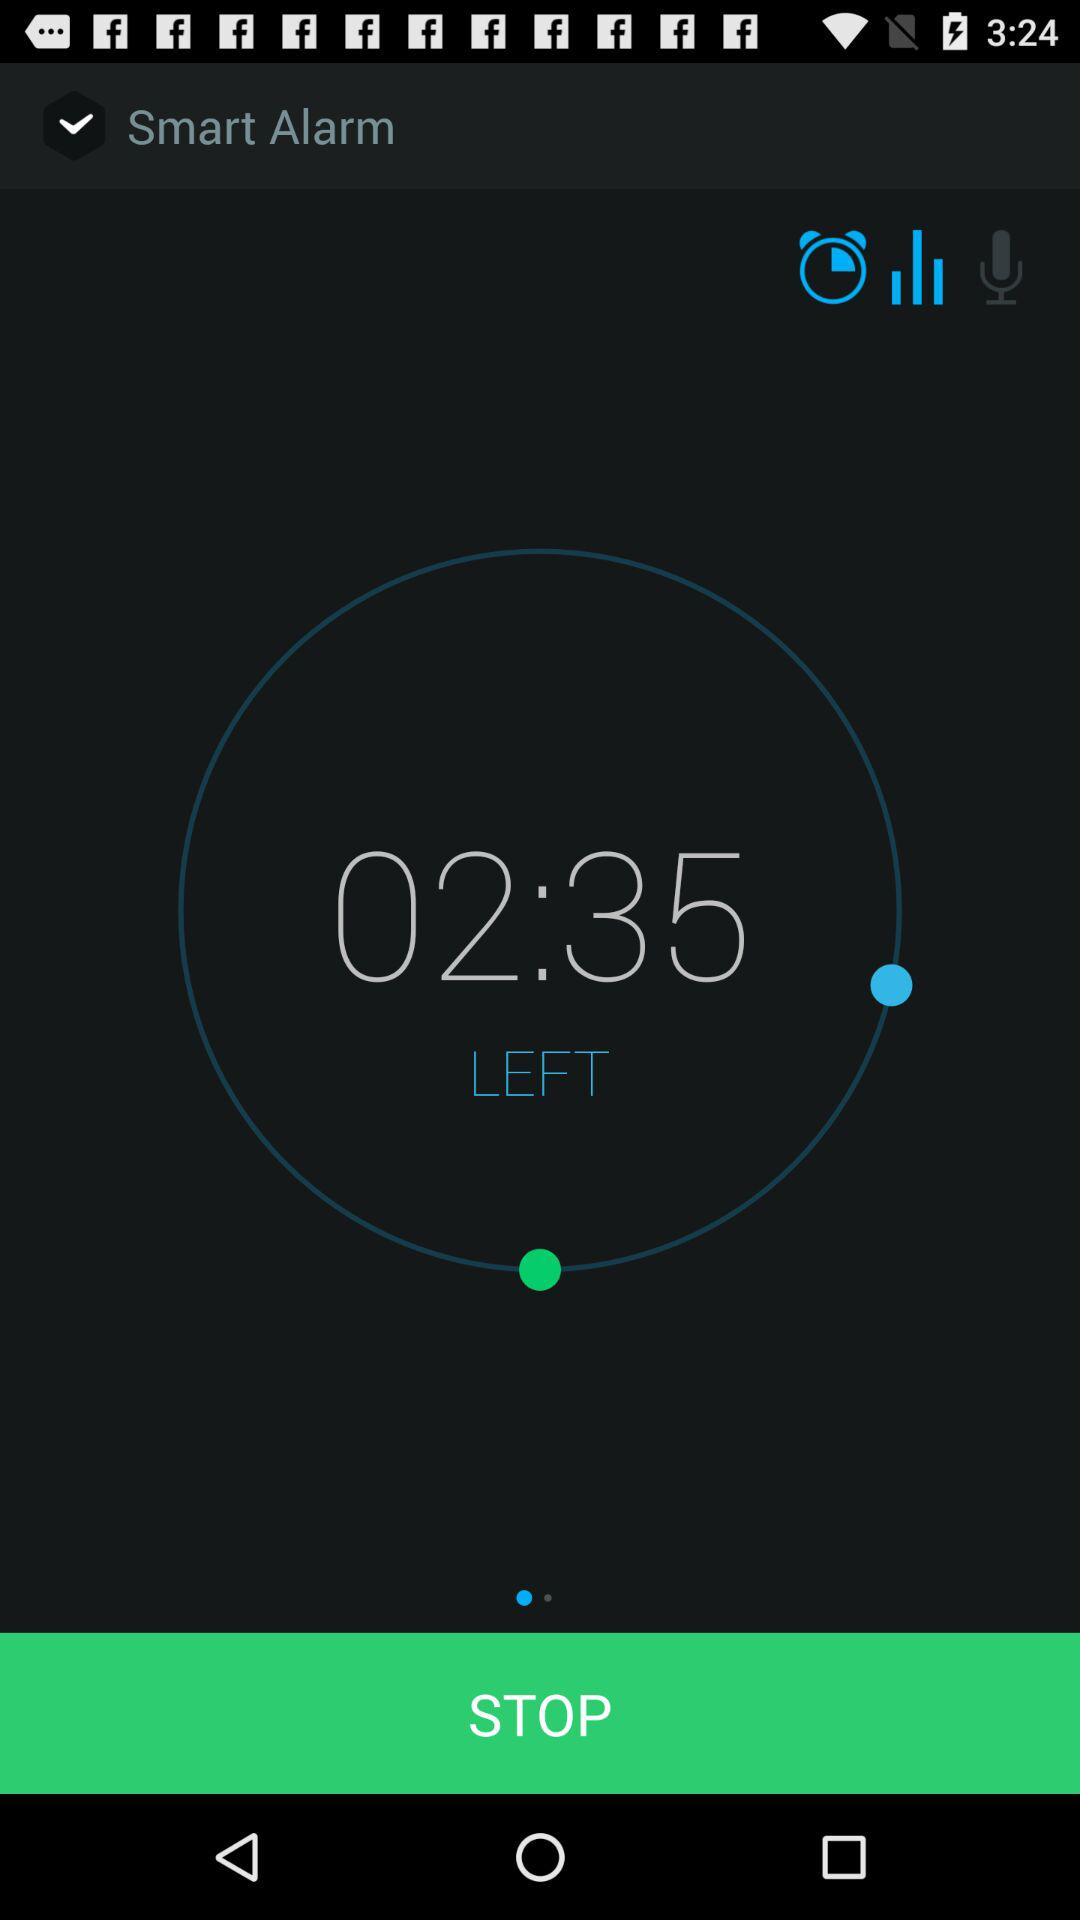How much time is left? The time left is 02:35. 